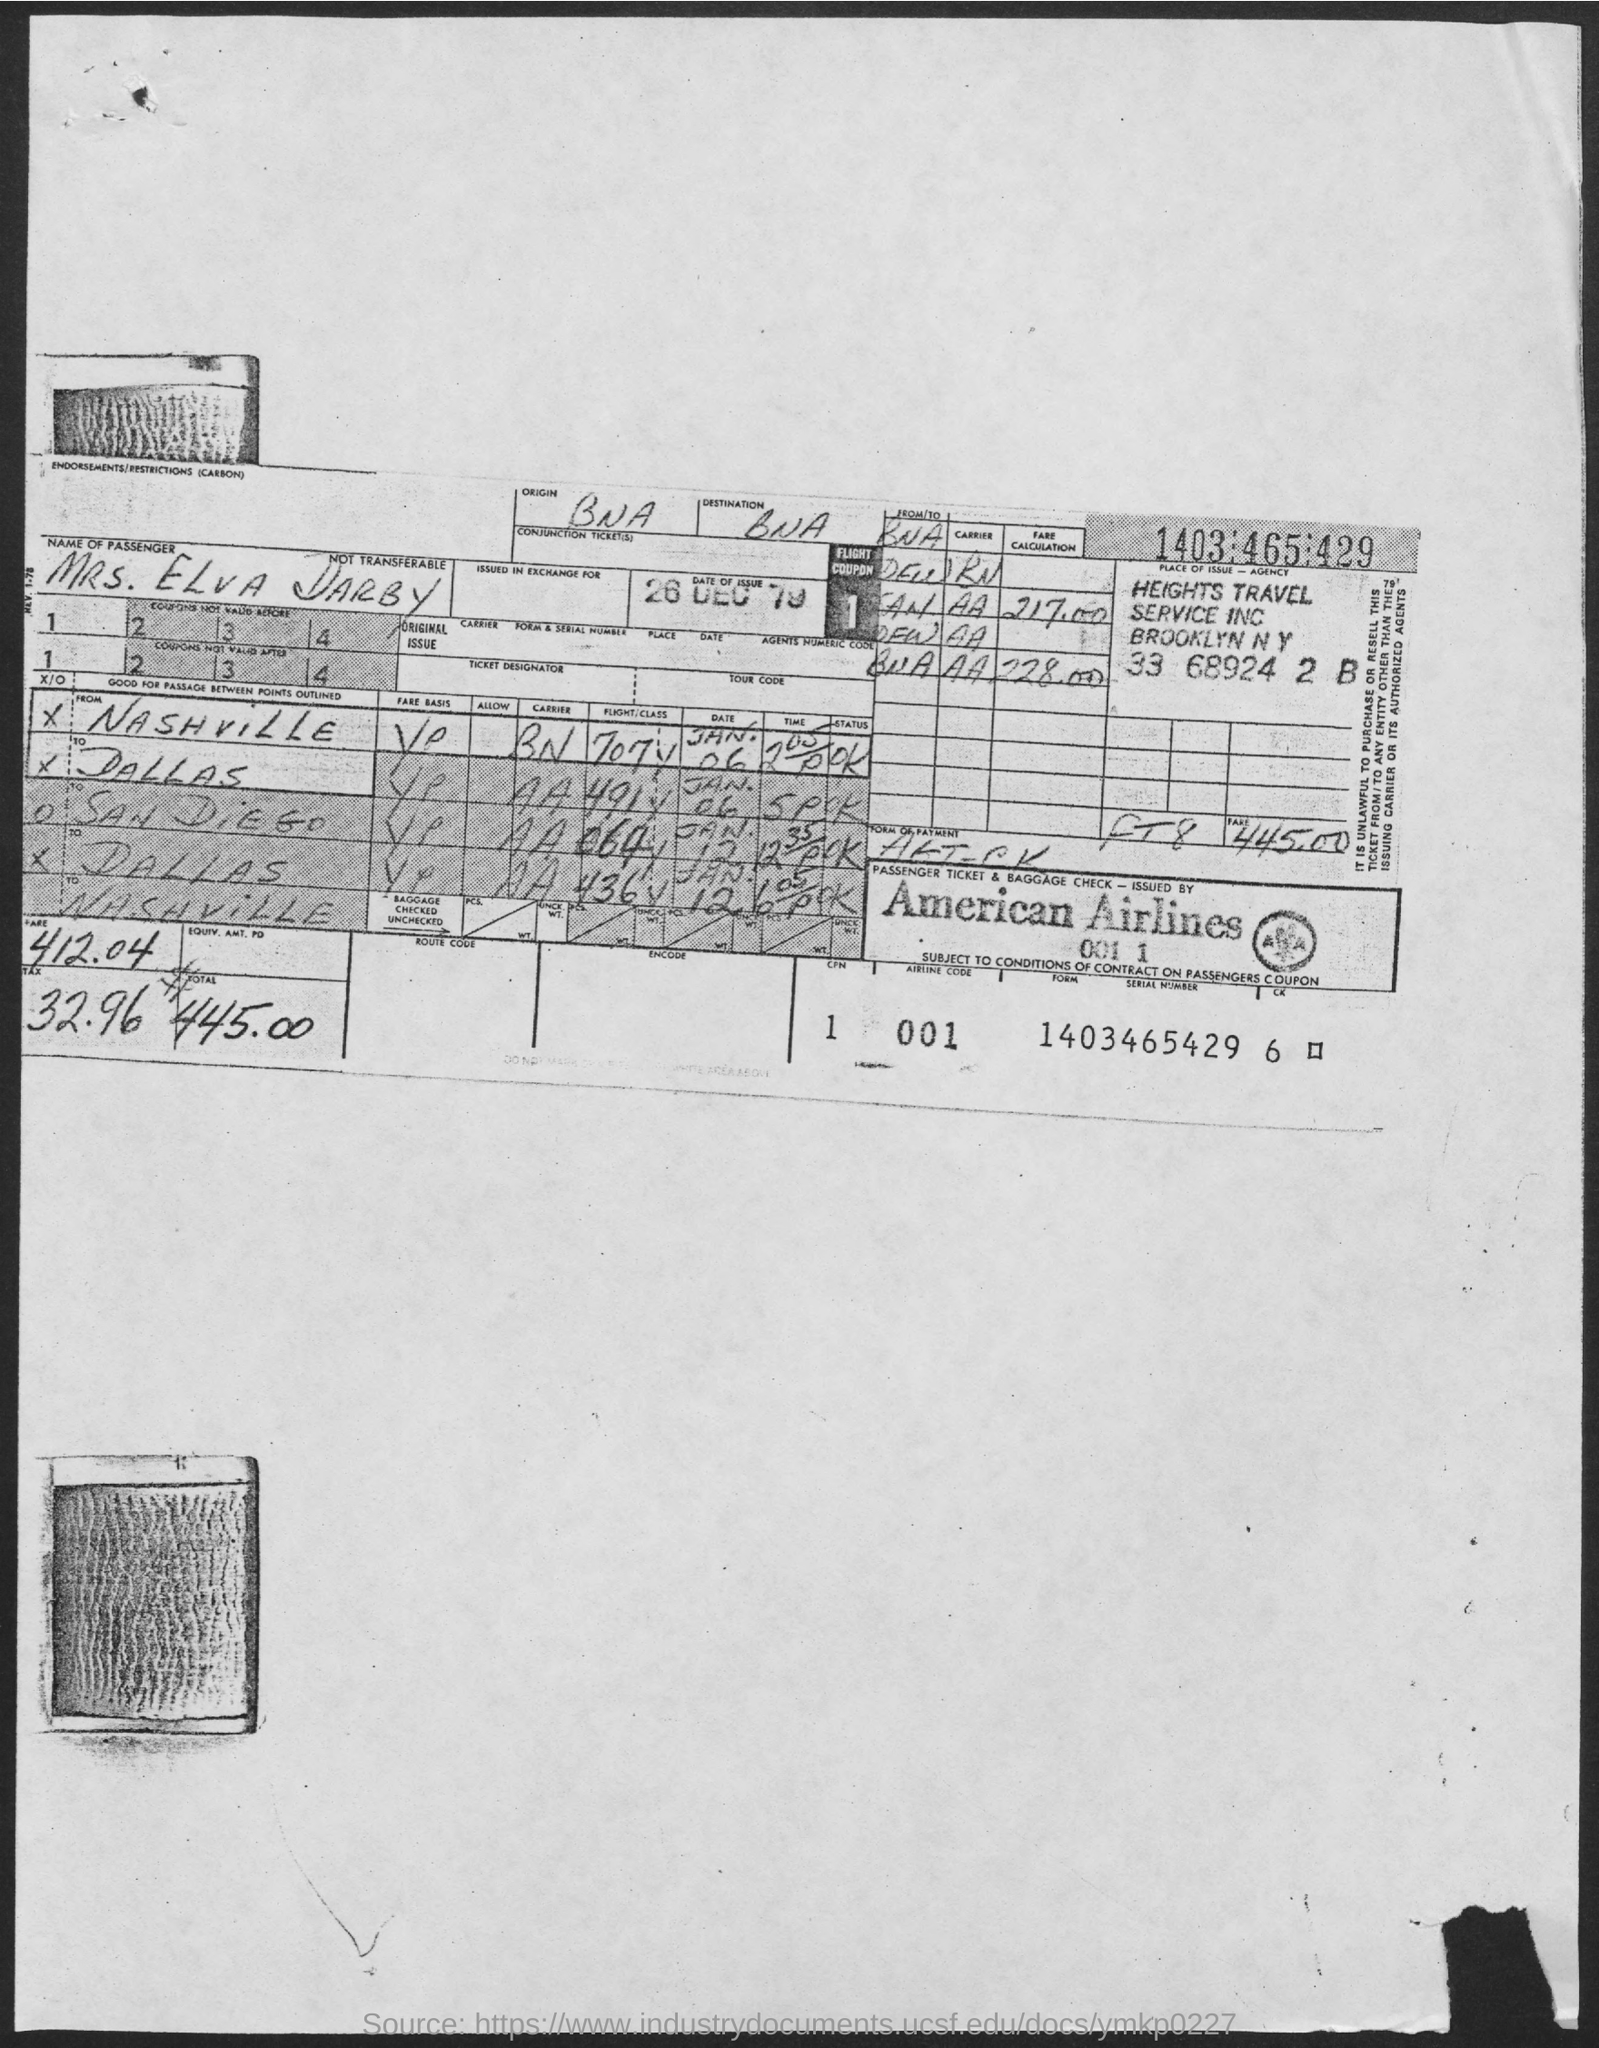What is the name of passenger?
Keep it short and to the point. Mrs. Elva Darby. What is the date of issue?
Your answer should be compact. 26 Dec 79. What is the airline code?
Offer a terse response. 001. 